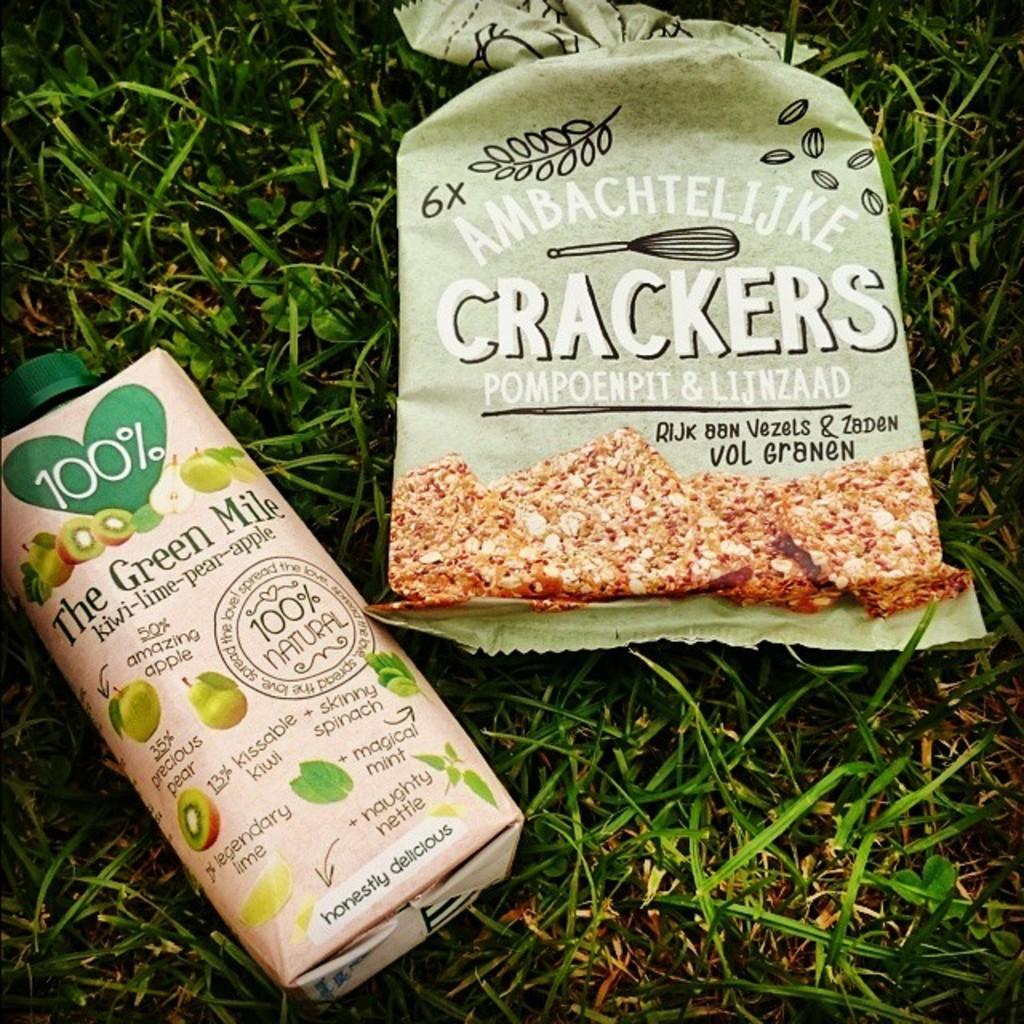Are the snacks 100% natural?
Make the answer very short. Yes. What kind of snacks are in the large bag?
Offer a terse response. Crackers. 